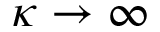<formula> <loc_0><loc_0><loc_500><loc_500>\kappa \to \infty</formula> 